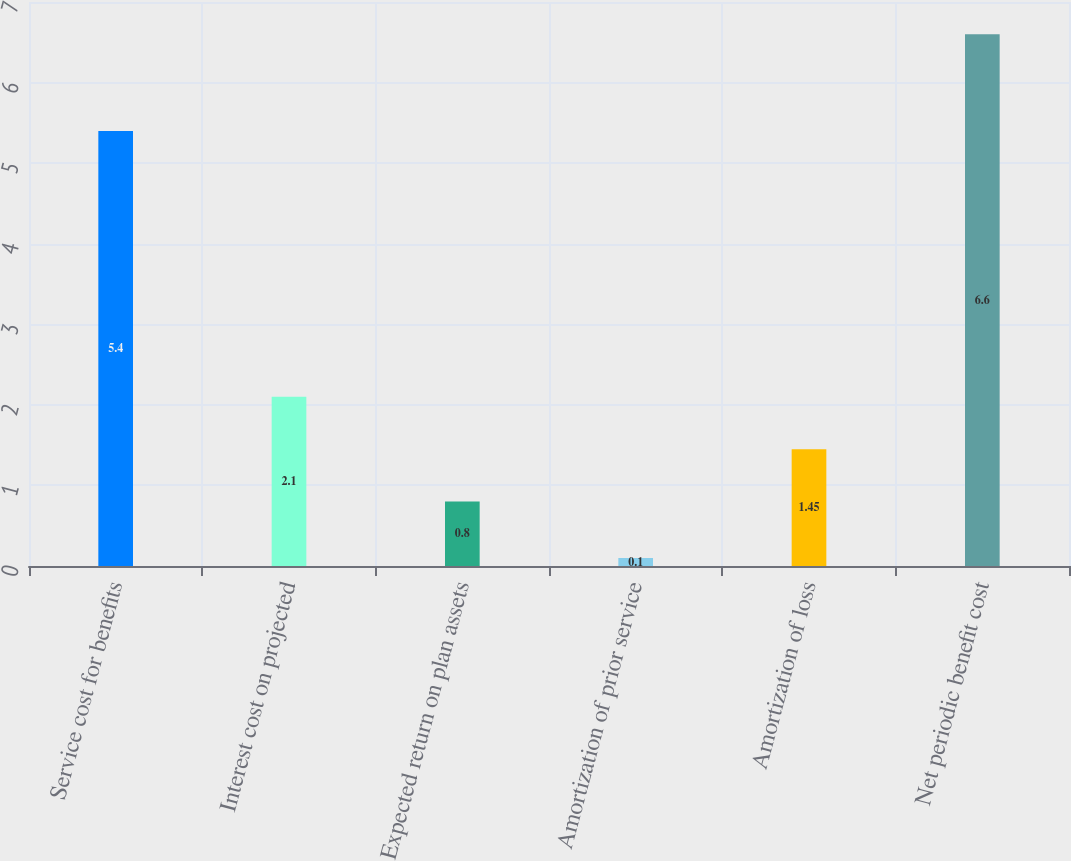<chart> <loc_0><loc_0><loc_500><loc_500><bar_chart><fcel>Service cost for benefits<fcel>Interest cost on projected<fcel>Expected return on plan assets<fcel>Amortization of prior service<fcel>Amortization of loss<fcel>Net periodic benefit cost<nl><fcel>5.4<fcel>2.1<fcel>0.8<fcel>0.1<fcel>1.45<fcel>6.6<nl></chart> 